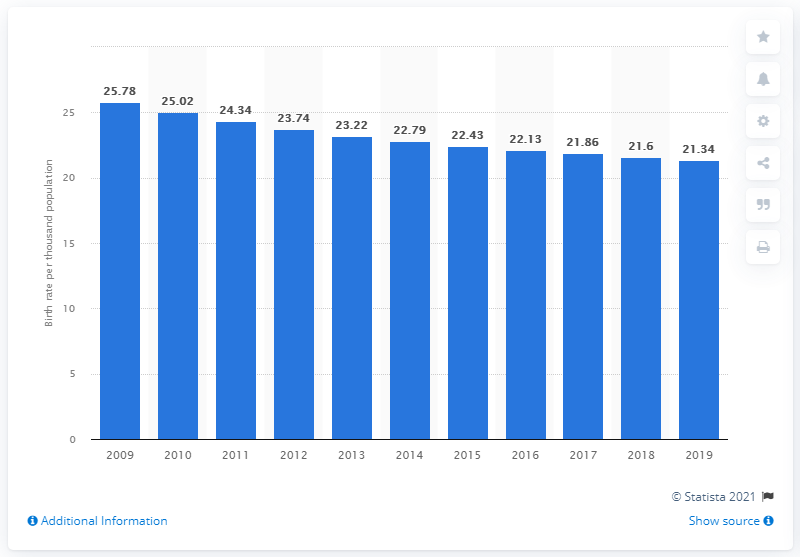Point out several critical features in this image. The crude birth rate in Honduras in 2019 was 21.34. 